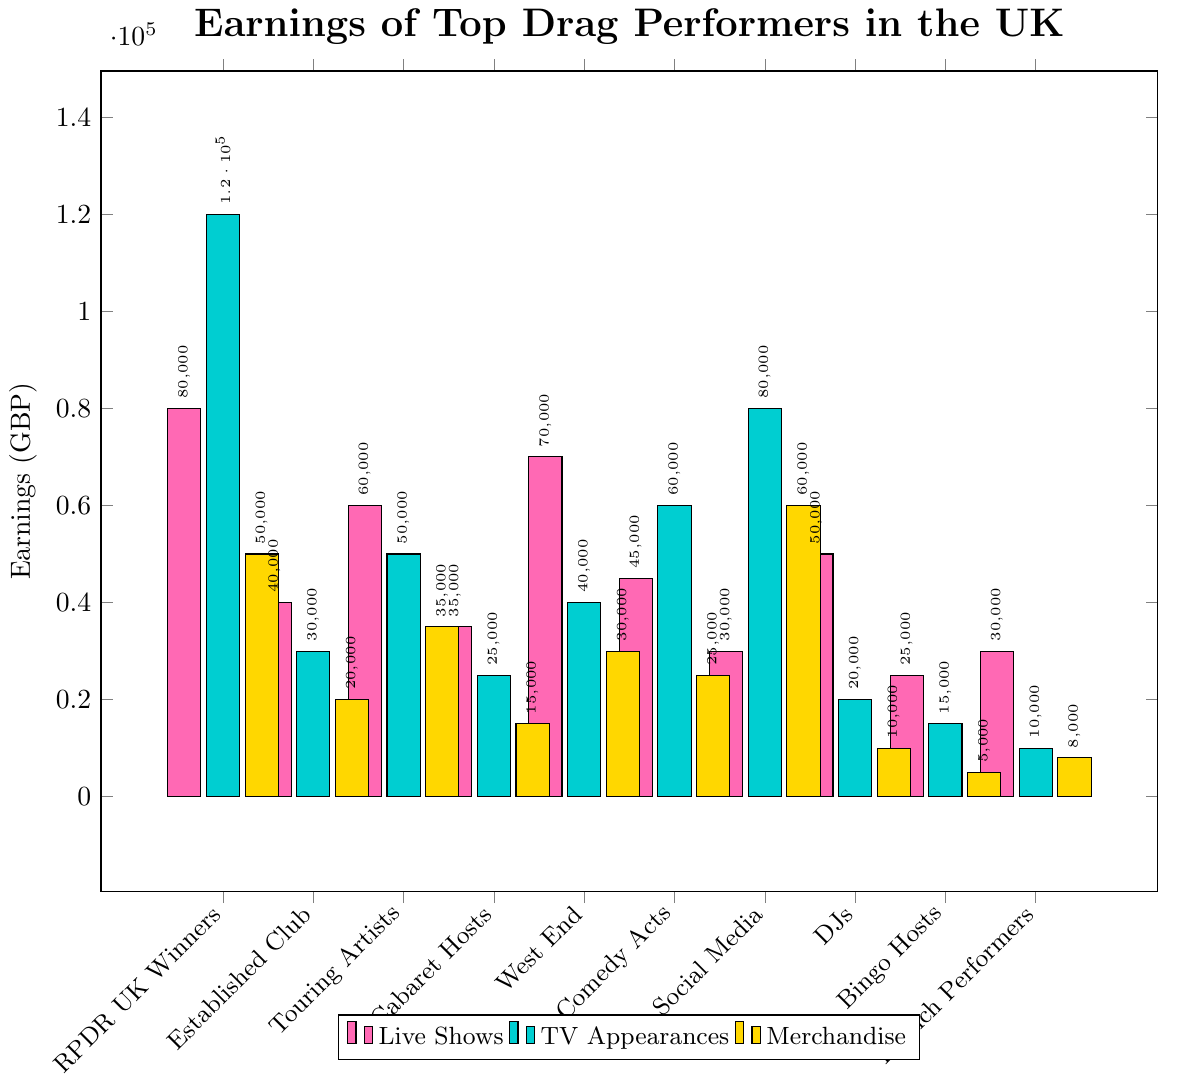Which category has the highest earnings from live shows? To find the category with the highest earnings from live shows, look at the bars colored in pink and identify the tallest one. The bar for "RuPaul's Drag Race UK Winners" is the tallest in the pink category.
Answer: RuPaul's Drag Race UK Winners Which performance type brings the most earnings for Social Media Drag Influencers? Look at the three bars related to Social Media Drag Influencers (Live Shows, TV Appearances, Merchandise). The tallest bar (colored in blue) corresponds to TV Appearances.
Answer: TV Appearances What is the total earnings from TV appearances for Drag Comedy Acts and Drag DJs combined? Add the earnings from TV appearances for Drag Comedy Acts (60000) and Drag DJs (20000). The total is 60000 + 20000.
Answer: 80000 By how much do the earnings from live shows for West End Drag Performers exceed those from TV appearances? Subtract the TV appearances earnings (40000) from the live shows earnings (70000) for West End Drag Performers. 70000 - 40000.
Answer: 30000 Rank the earnings from merchandise of the categories in descending order. List the categories based on their merchandise earnings from highest to lowest using the height of the yellow bars. The order is Social Media Drag Influencers (60000), RPDR UK Winners (50000), Touring Drag Artists (35000), West End Drag Performers (30000), Drag Comedy Acts (25000), Established Club Performers (20000), Drag Cabaret Hosts (15000), Drag Brunch Performers (8000), Drag DJs (10000), Drag Bingo Hosts (5000).
Answer: Social Media Drag Influencers, RPDR UK Winners, Touring Drag Artists, West End Drag Performers, Drag Comedy Acts, Established Club Performers, Drag Cabaret Hosts, Drag Brunch Performers, Drag DJs, Drag Bingo Hosts For which category is the earnings gap between live shows and merchandise the smallest? To find this, compute the absolute difference between the live shows and merchandise earnings for each category and identify the smallest gap.
Answer: Drag DJs Which category has the lowest total earnings from all performance types combined? Calculate the total earnings for each category by summing their earnings from live shows, TV appearances, and merchandise, then identify the smallest total.
Answer: Drag Brunch Performers How much more does the highest earner overall make from TV appearances compared to the highest earner from live shows? The highest TV appearance earnings are for RPDR UK Winners (120000). The highest live show earnings are also for RPDR UK Winners (80000). Subtract the live show earnings from the TV appearance earnings. 120000 - 80000.
Answer: 40000 